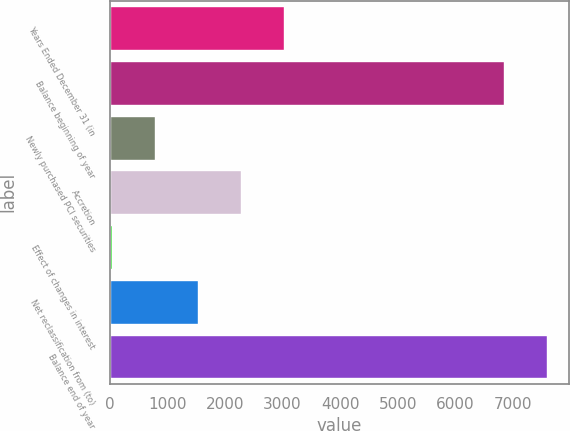<chart> <loc_0><loc_0><loc_500><loc_500><bar_chart><fcel>Years Ended December 31 (in<fcel>Balance beginning of year<fcel>Newly purchased PCI securities<fcel>Accretion<fcel>Effect of changes in interest<fcel>Net reclassification from (to)<fcel>Balance end of year<nl><fcel>3022.6<fcel>6846<fcel>784.9<fcel>2276.7<fcel>39<fcel>1530.8<fcel>7591.9<nl></chart> 